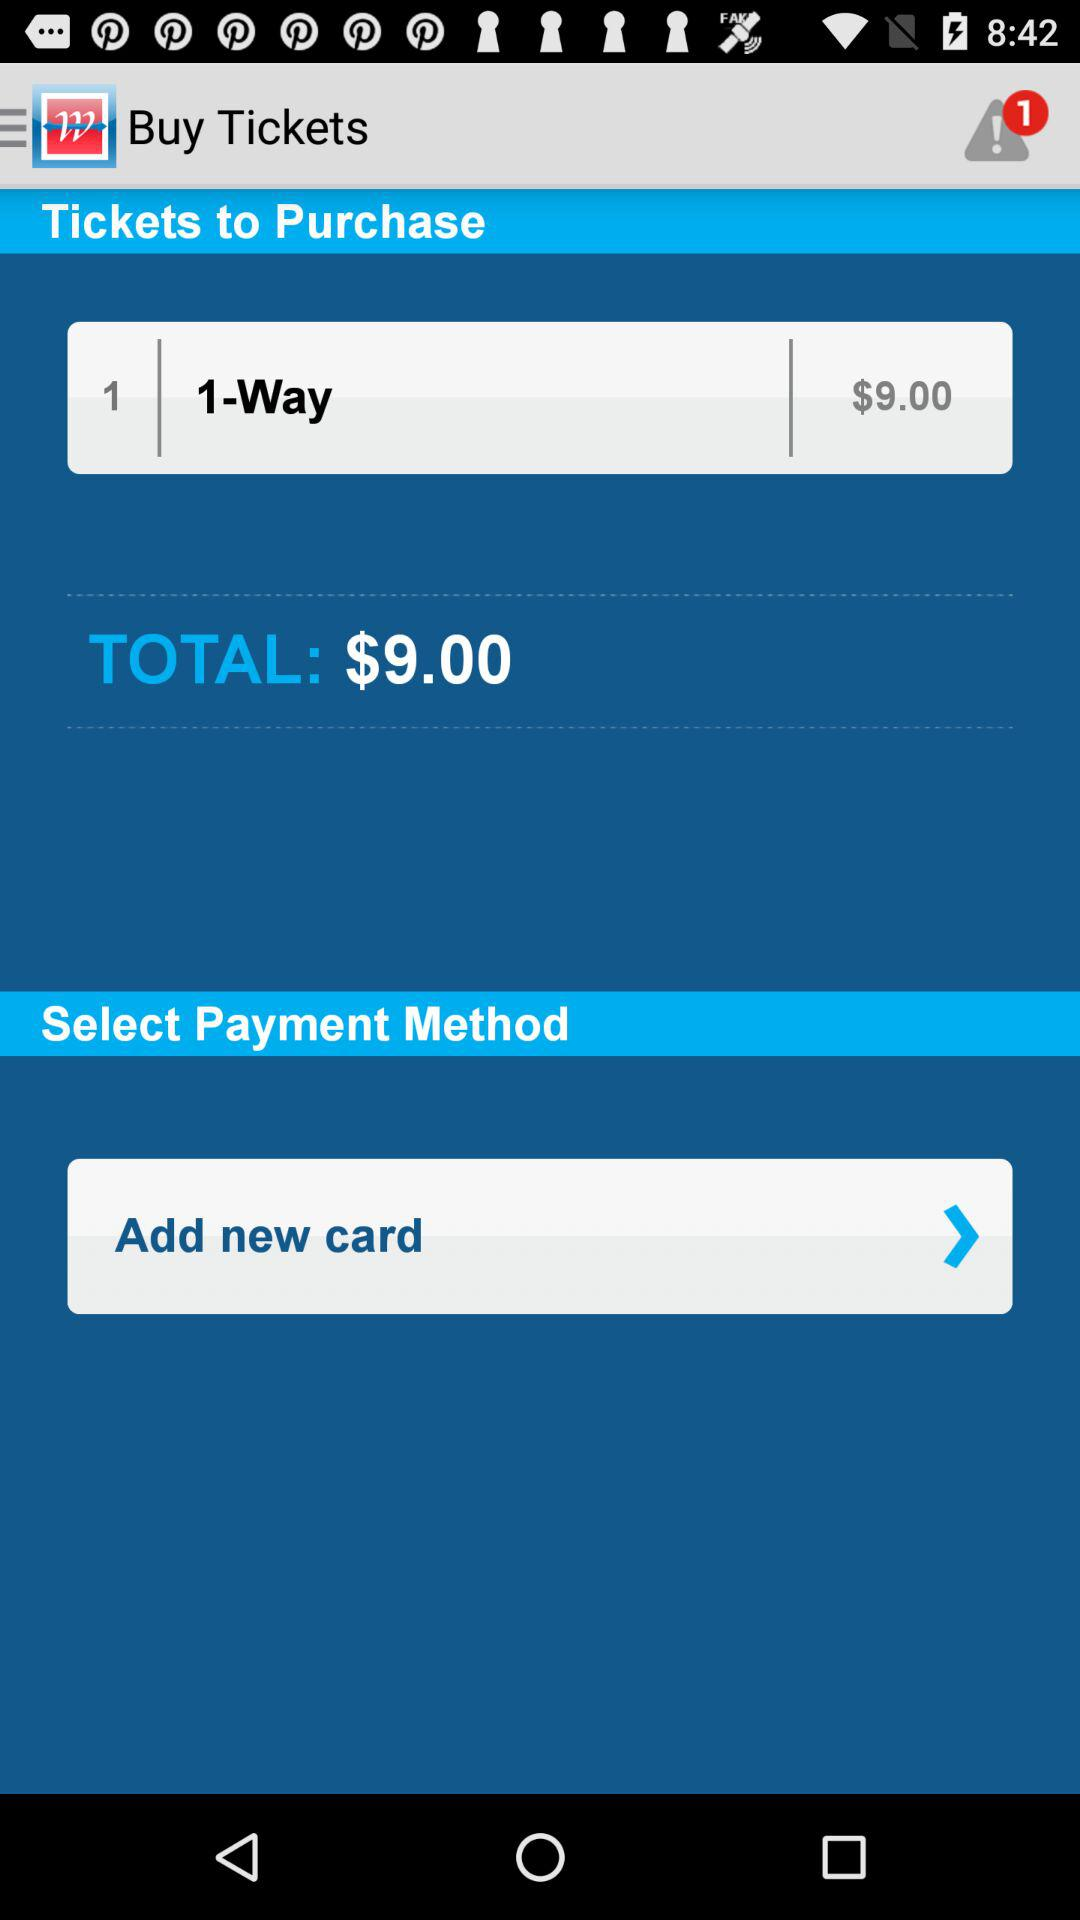What is the total fare for one way? The total fare is $9.00. 